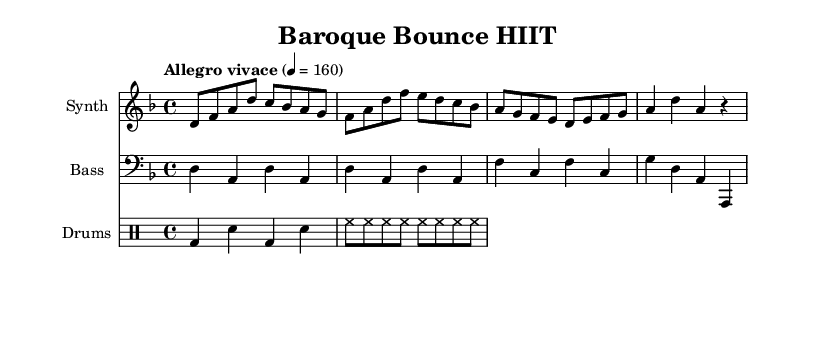What is the key signature of this music? The key signature is indicated by the number of flats or sharps at the beginning of the staff. In this case, it has a flat on B, indicating that the key signature is D minor.
Answer: D minor What is the time signature of this music? The time signature is located at the beginning of the score and shows the note values and beats per measure. Here, it is 4/4, which means there are four beats in a measure and the quarter note gets one beat.
Answer: 4/4 What is the tempo marking of this music? The tempo marking is typically placed at the beginning of the score. In this case, it says "Allegro vivace" with a metronome marking of 160, indicating a fast and lively pace.
Answer: Allegro vivace How many measures are in the main theme? The main theme is written in a series of measures, and counting them gives the total. There are four measures in the main theme section visible in the score.
Answer: 4 What type of instruments are featured in this score? The score includes specific labels for each staff, indicating the type of instruments being used. Here, there is a staff for "Synth," "Bass," and "Drums," showing the electronic ensemble used in this remix.
Answer: Synth, Bass, Drums What is the rhythmic pattern used for the drums? The drum pattern consists of specific rhythmic values laid out in a structured way. The pattern alternates between bass drum beats and snare hits, followed by a consistent hi-hat rhythm, indicating a typical four-beat pattern.
Answer: Bass and snare alternation with hi-hat What is the harmonic movement in the bass line? The bass line shows the notes play a foundational support under the main theme. Observing the bass notes reveals a pattern that alternates between D and A, fitting within the key of D minor, establishing a harmonic progression.
Answer: Harmonic progression of D and A 